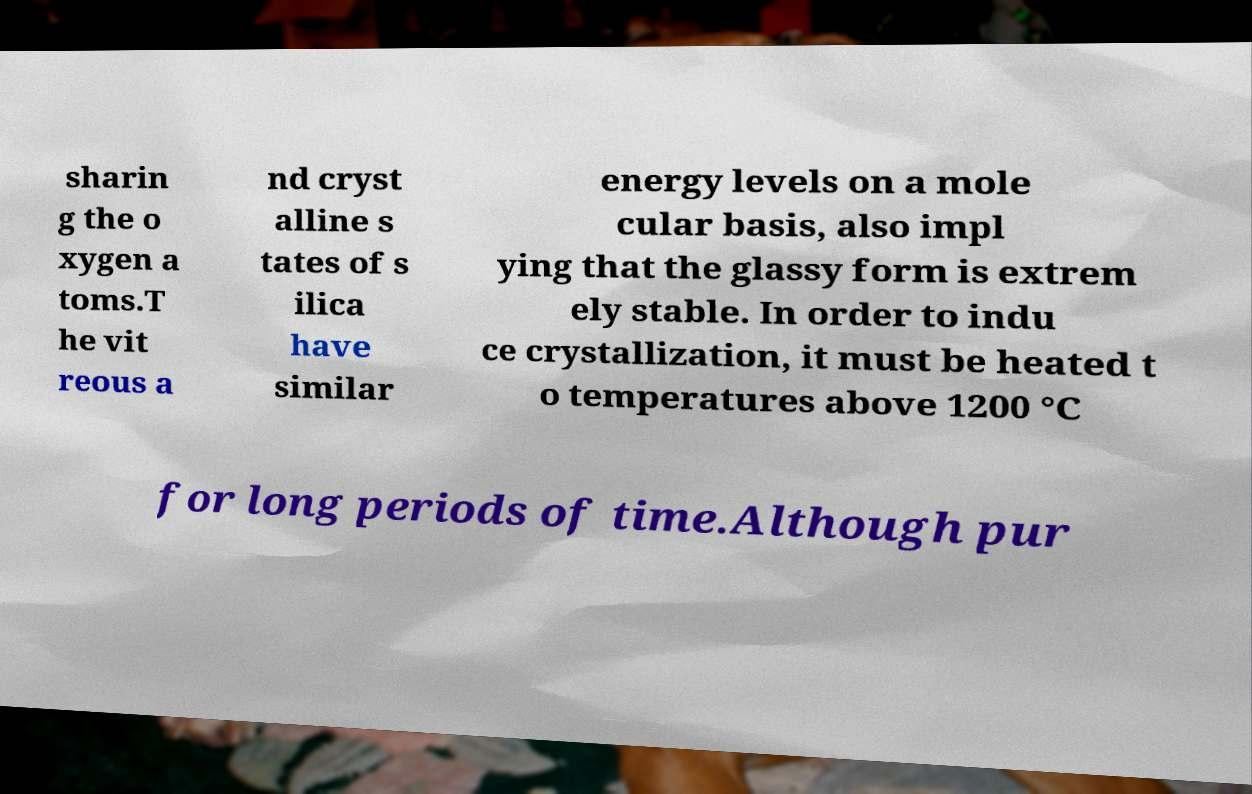Please identify and transcribe the text found in this image. sharin g the o xygen a toms.T he vit reous a nd cryst alline s tates of s ilica have similar energy levels on a mole cular basis, also impl ying that the glassy form is extrem ely stable. In order to indu ce crystallization, it must be heated t o temperatures above 1200 °C for long periods of time.Although pur 